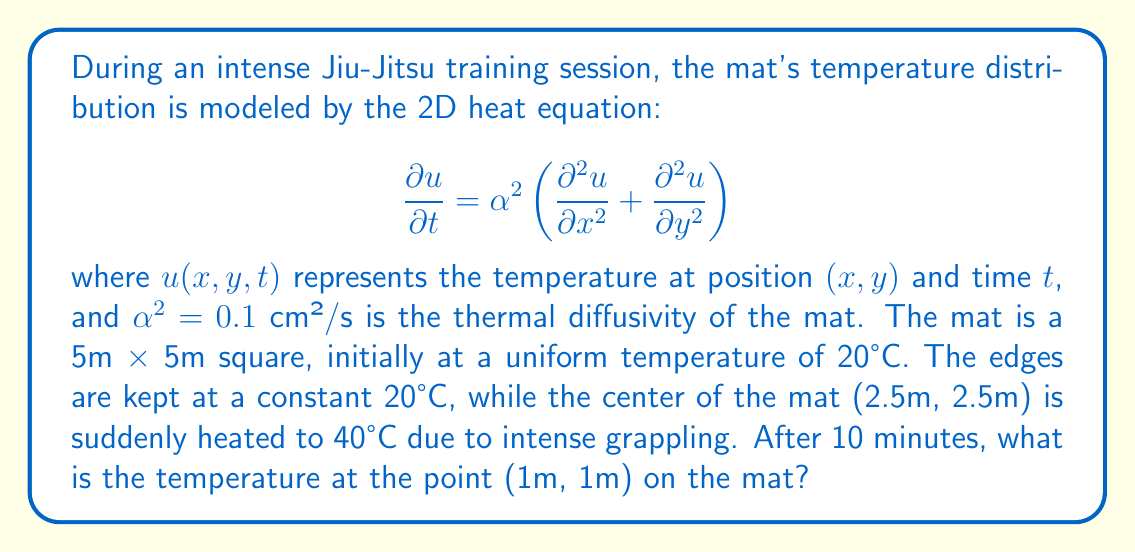Solve this math problem. To solve this problem, we need to use the solution to the 2D heat equation with the given initial and boundary conditions. The solution can be expressed as a double Fourier series:

$$u(x,y,t) = 20 + \sum_{m=1}^{\infty}\sum_{n=1}^{\infty} A_{mn} \sin\left(\frac{m\pi x}{L}\right)\sin\left(\frac{n\pi y}{L}\right)e^{-\alpha^2(m^2+n^2)\pi^2t/L^2}$$

where $L = 5$ m is the length of the square mat, and $A_{mn}$ are the Fourier coefficients.

Given the initial condition of a point heat source at the center, we can approximate the coefficients as:

$$A_{mn} = \frac{4}{L^2} \int_0^L \int_0^L (u_0(x,y) - 20) \sin\left(\frac{m\pi x}{L}\right)\sin\left(\frac{n\pi y}{L}\right) dx dy$$

where $u_0(x,y)$ is the initial temperature distribution. Approximating the point source as a small square of size $\epsilon$, we get:

$$A_{mn} \approx \frac{4}{L^2} \cdot 20 \cdot \epsilon^2 \sin\left(\frac{m\pi L/2}{L}\right)\sin\left(\frac{n\pi L/2}{L}\right) = \frac{80\epsilon^2}{L^2} \sin\left(\frac{m\pi}{2}\right)\sin\left(\frac{n\pi}{2}\right)$$

Now, we can calculate the temperature at (1m, 1m) after 10 minutes:

$$u(1,1,600) = 20 + \sum_{m=1}^{\infty}\sum_{n=1}^{\infty} \frac{80\epsilon^2}{25} \sin\left(\frac{m\pi}{2}\right)\sin\left(\frac{n\pi}{2}\right) \sin\left(\frac{m\pi}{5}\right)\sin\left(\frac{n\pi}{5}\right)e^{-0.1(m^2+n^2)\pi^2\cdot 600/25}$$

Using a numerical approximation with a finite number of terms (e.g., m, n up to 50) and a small $\epsilon$ (e.g., 0.1), we can evaluate this sum to get the final temperature.
Answer: Approximately 20.8°C 